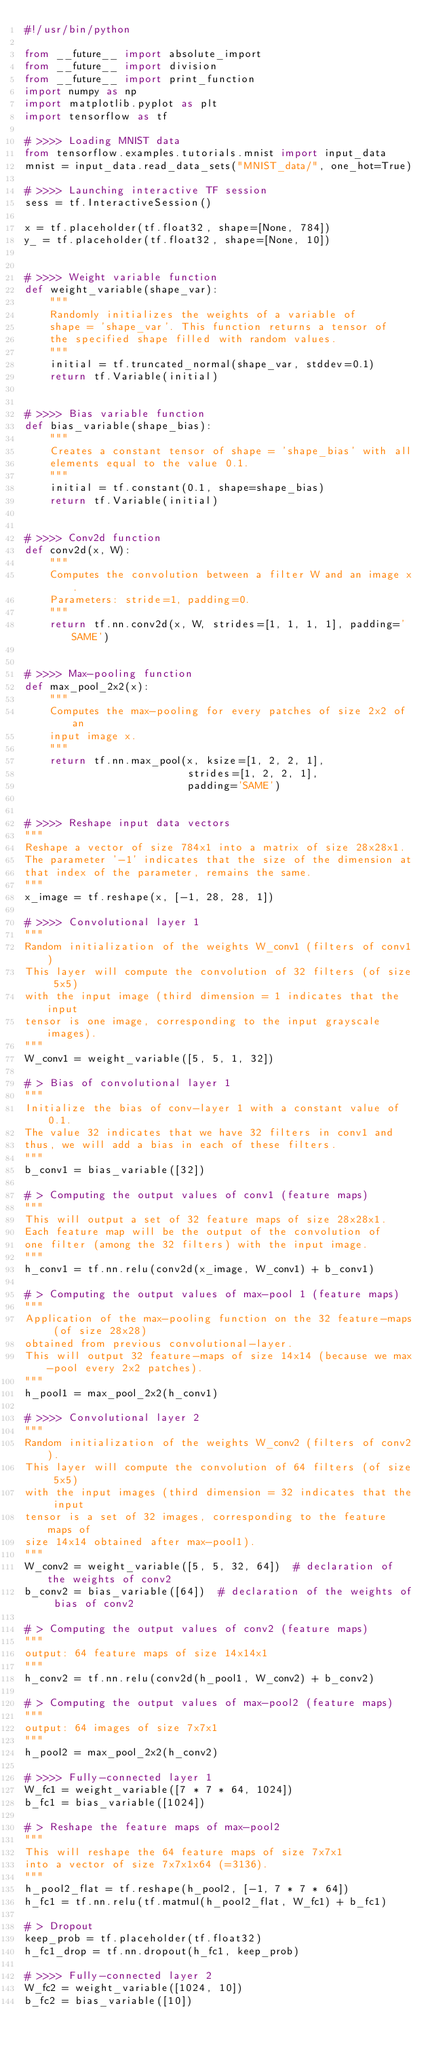Convert code to text. <code><loc_0><loc_0><loc_500><loc_500><_Python_>#!/usr/bin/python

from __future__ import absolute_import
from __future__ import division
from __future__ import print_function
import numpy as np
import matplotlib.pyplot as plt
import tensorflow as tf

# >>>> Loading MNIST data
from tensorflow.examples.tutorials.mnist import input_data
mnist = input_data.read_data_sets("MNIST_data/", one_hot=True)

# >>>> Launching interactive TF session
sess = tf.InteractiveSession()

x = tf.placeholder(tf.float32, shape=[None, 784])
y_ = tf.placeholder(tf.float32, shape=[None, 10])


# >>>> Weight variable function
def weight_variable(shape_var):
    """
    Randomly initializes the weights of a variable of
    shape = 'shape_var'. This function returns a tensor of
    the specified shape filled with random values.
    """
    initial = tf.truncated_normal(shape_var, stddev=0.1)
    return tf.Variable(initial)


# >>>> Bias variable function
def bias_variable(shape_bias):
    """
    Creates a constant tensor of shape = 'shape_bias' with all
    elements equal to the value 0.1.
    """
    initial = tf.constant(0.1, shape=shape_bias)
    return tf.Variable(initial)


# >>>> Conv2d function
def conv2d(x, W):
    """
    Computes the convolution between a filter W and an image x.
    Parameters: stride=1, padding=0.
    """
    return tf.nn.conv2d(x, W, strides=[1, 1, 1, 1], padding='SAME')


# >>>> Max-pooling function
def max_pool_2x2(x):
    """
    Computes the max-pooling for every patches of size 2x2 of an
    input image x.
    """
    return tf.nn.max_pool(x, ksize=[1, 2, 2, 1],
                          strides=[1, 2, 2, 1],
                          padding='SAME')


# >>>> Reshape input data vectors
"""
Reshape a vector of size 784x1 into a matrix of size 28x28x1.
The parameter '-1' indicates that the size of the dimension at
that index of the parameter, remains the same.
"""
x_image = tf.reshape(x, [-1, 28, 28, 1])

# >>>> Convolutional layer 1
"""
Random initialization of the weights W_conv1 (filters of conv1)
This layer will compute the convolution of 32 filters (of size 5x5)
with the input image (third dimension = 1 indicates that the input
tensor is one image, corresponding to the input grayscale images).
"""
W_conv1 = weight_variable([5, 5, 1, 32])

# > Bias of convolutional layer 1
"""
Initialize the bias of conv-layer 1 with a constant value of 0.1.
The value 32 indicates that we have 32 filters in conv1 and
thus, we will add a bias in each of these filters.
"""
b_conv1 = bias_variable([32])

# > Computing the output values of conv1 (feature maps)
"""
This will output a set of 32 feature maps of size 28x28x1.
Each feature map will be the output of the convolution of
one filter (among the 32 filters) with the input image.
"""
h_conv1 = tf.nn.relu(conv2d(x_image, W_conv1) + b_conv1)

# > Computing the output values of max-pool 1 (feature maps)
"""
Application of the max-pooling function on the 32 feature-maps (of size 28x28)
obtained from previous convolutional-layer.
This will output 32 feature-maps of size 14x14 (because we max-pool every 2x2 patches).
"""
h_pool1 = max_pool_2x2(h_conv1)

# >>>> Convolutional layer 2
"""
Random initialization of the weights W_conv2 (filters of conv2).
This layer will compute the convolution of 64 filters (of size 5x5)
with the input images (third dimension = 32 indicates that the input
tensor is a set of 32 images, corresponding to the feature maps of
size 14x14 obtained after max-pool1).
"""
W_conv2 = weight_variable([5, 5, 32, 64])  # declaration of the weights of conv2
b_conv2 = bias_variable([64])  # declaration of the weights of bias of conv2

# > Computing the output values of conv2 (feature maps)
"""
output: 64 feature maps of size 14x14x1
"""
h_conv2 = tf.nn.relu(conv2d(h_pool1, W_conv2) + b_conv2)

# > Computing the output values of max-pool2 (feature maps)
"""
output: 64 images of size 7x7x1
"""
h_pool2 = max_pool_2x2(h_conv2)

# >>>> Fully-connected layer 1
W_fc1 = weight_variable([7 * 7 * 64, 1024])
b_fc1 = bias_variable([1024])

# > Reshape the feature maps of max-pool2
"""
This will reshape the 64 feature maps of size 7x7x1
into a vector of size 7x7x1x64 (=3136).
"""
h_pool2_flat = tf.reshape(h_pool2, [-1, 7 * 7 * 64])
h_fc1 = tf.nn.relu(tf.matmul(h_pool2_flat, W_fc1) + b_fc1)

# > Dropout
keep_prob = tf.placeholder(tf.float32)
h_fc1_drop = tf.nn.dropout(h_fc1, keep_prob)

# >>>> Fully-connected layer 2
W_fc2 = weight_variable([1024, 10])
b_fc2 = bias_variable([10])</code> 